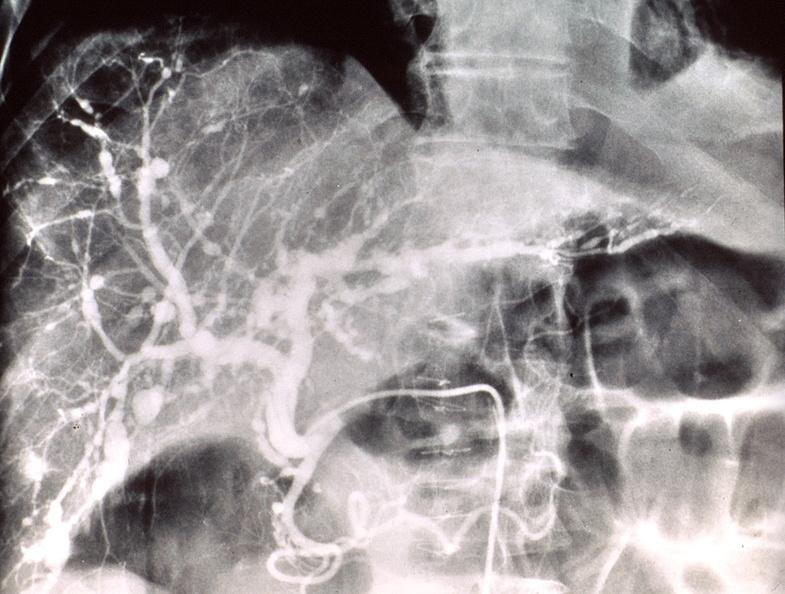what does this image show?
Answer the question using a single word or phrase. Poly arteritis nodosa 